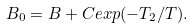<formula> <loc_0><loc_0><loc_500><loc_500>B _ { 0 } = B + C e x p ( - T _ { 2 } / T ) .</formula> 